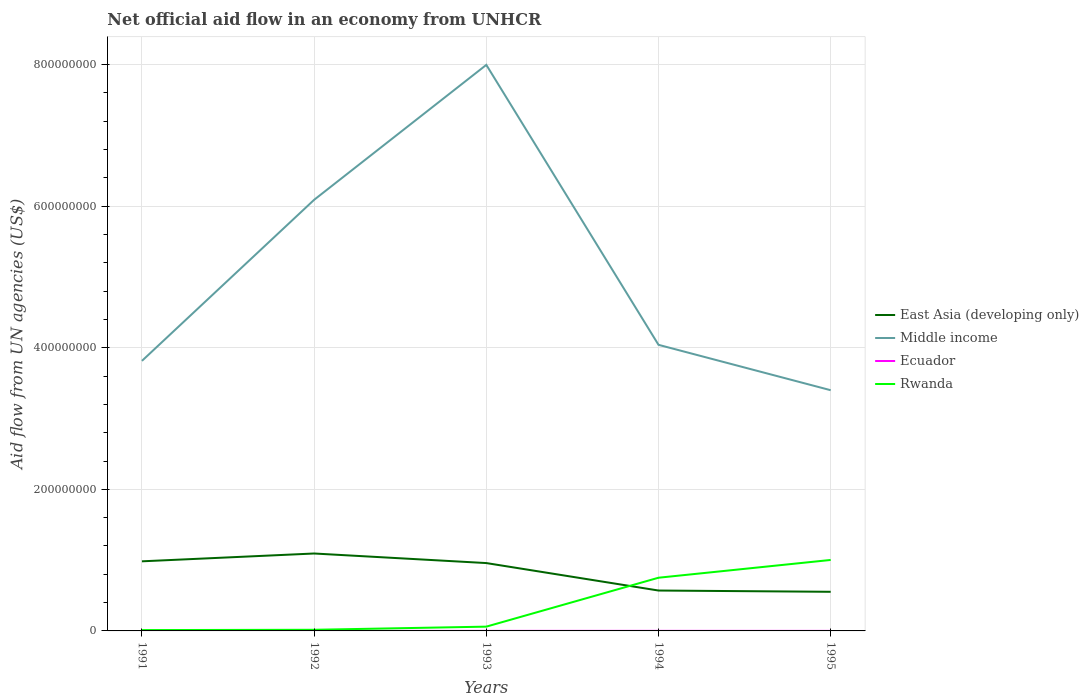Does the line corresponding to Middle income intersect with the line corresponding to East Asia (developing only)?
Provide a short and direct response. No. Across all years, what is the maximum net official aid flow in East Asia (developing only)?
Keep it short and to the point. 5.53e+07. What is the difference between the highest and the second highest net official aid flow in Rwanda?
Make the answer very short. 9.90e+07. How many lines are there?
Offer a terse response. 4. How many years are there in the graph?
Provide a succinct answer. 5. Are the values on the major ticks of Y-axis written in scientific E-notation?
Keep it short and to the point. No. How many legend labels are there?
Offer a terse response. 4. What is the title of the graph?
Give a very brief answer. Net official aid flow in an economy from UNHCR. Does "Luxembourg" appear as one of the legend labels in the graph?
Give a very brief answer. No. What is the label or title of the Y-axis?
Your answer should be compact. Aid flow from UN agencies (US$). What is the Aid flow from UN agencies (US$) in East Asia (developing only) in 1991?
Ensure brevity in your answer.  9.83e+07. What is the Aid flow from UN agencies (US$) of Middle income in 1991?
Keep it short and to the point. 3.81e+08. What is the Aid flow from UN agencies (US$) in Ecuador in 1991?
Keep it short and to the point. 1.00e+05. What is the Aid flow from UN agencies (US$) in Rwanda in 1991?
Make the answer very short. 1.20e+06. What is the Aid flow from UN agencies (US$) of East Asia (developing only) in 1992?
Give a very brief answer. 1.09e+08. What is the Aid flow from UN agencies (US$) of Middle income in 1992?
Offer a terse response. 6.09e+08. What is the Aid flow from UN agencies (US$) of Rwanda in 1992?
Keep it short and to the point. 1.61e+06. What is the Aid flow from UN agencies (US$) of East Asia (developing only) in 1993?
Provide a short and direct response. 9.58e+07. What is the Aid flow from UN agencies (US$) in Middle income in 1993?
Your answer should be very brief. 8.00e+08. What is the Aid flow from UN agencies (US$) of Ecuador in 1993?
Your answer should be very brief. 7.00e+04. What is the Aid flow from UN agencies (US$) in Rwanda in 1993?
Your answer should be compact. 6.05e+06. What is the Aid flow from UN agencies (US$) in East Asia (developing only) in 1994?
Keep it short and to the point. 5.70e+07. What is the Aid flow from UN agencies (US$) in Middle income in 1994?
Make the answer very short. 4.04e+08. What is the Aid flow from UN agencies (US$) in Ecuador in 1994?
Your response must be concise. 8.00e+04. What is the Aid flow from UN agencies (US$) of Rwanda in 1994?
Offer a very short reply. 7.51e+07. What is the Aid flow from UN agencies (US$) of East Asia (developing only) in 1995?
Your answer should be very brief. 5.53e+07. What is the Aid flow from UN agencies (US$) in Middle income in 1995?
Offer a terse response. 3.40e+08. What is the Aid flow from UN agencies (US$) in Ecuador in 1995?
Offer a terse response. 5.00e+04. What is the Aid flow from UN agencies (US$) in Rwanda in 1995?
Your answer should be very brief. 1.00e+08. Across all years, what is the maximum Aid flow from UN agencies (US$) of East Asia (developing only)?
Ensure brevity in your answer.  1.09e+08. Across all years, what is the maximum Aid flow from UN agencies (US$) in Middle income?
Your answer should be very brief. 8.00e+08. Across all years, what is the maximum Aid flow from UN agencies (US$) of Ecuador?
Offer a very short reply. 1.00e+05. Across all years, what is the maximum Aid flow from UN agencies (US$) in Rwanda?
Make the answer very short. 1.00e+08. Across all years, what is the minimum Aid flow from UN agencies (US$) of East Asia (developing only)?
Give a very brief answer. 5.53e+07. Across all years, what is the minimum Aid flow from UN agencies (US$) of Middle income?
Offer a terse response. 3.40e+08. Across all years, what is the minimum Aid flow from UN agencies (US$) of Ecuador?
Your answer should be compact. 5.00e+04. Across all years, what is the minimum Aid flow from UN agencies (US$) of Rwanda?
Your response must be concise. 1.20e+06. What is the total Aid flow from UN agencies (US$) of East Asia (developing only) in the graph?
Provide a short and direct response. 4.16e+08. What is the total Aid flow from UN agencies (US$) of Middle income in the graph?
Ensure brevity in your answer.  2.53e+09. What is the total Aid flow from UN agencies (US$) of Ecuador in the graph?
Your answer should be compact. 3.90e+05. What is the total Aid flow from UN agencies (US$) in Rwanda in the graph?
Keep it short and to the point. 1.84e+08. What is the difference between the Aid flow from UN agencies (US$) of East Asia (developing only) in 1991 and that in 1992?
Give a very brief answer. -1.10e+07. What is the difference between the Aid flow from UN agencies (US$) in Middle income in 1991 and that in 1992?
Give a very brief answer. -2.27e+08. What is the difference between the Aid flow from UN agencies (US$) of Ecuador in 1991 and that in 1992?
Offer a terse response. 10000. What is the difference between the Aid flow from UN agencies (US$) of Rwanda in 1991 and that in 1992?
Your answer should be compact. -4.10e+05. What is the difference between the Aid flow from UN agencies (US$) in East Asia (developing only) in 1991 and that in 1993?
Your answer should be compact. 2.47e+06. What is the difference between the Aid flow from UN agencies (US$) in Middle income in 1991 and that in 1993?
Ensure brevity in your answer.  -4.18e+08. What is the difference between the Aid flow from UN agencies (US$) of Rwanda in 1991 and that in 1993?
Provide a short and direct response. -4.85e+06. What is the difference between the Aid flow from UN agencies (US$) of East Asia (developing only) in 1991 and that in 1994?
Provide a short and direct response. 4.13e+07. What is the difference between the Aid flow from UN agencies (US$) in Middle income in 1991 and that in 1994?
Give a very brief answer. -2.27e+07. What is the difference between the Aid flow from UN agencies (US$) in Ecuador in 1991 and that in 1994?
Offer a terse response. 2.00e+04. What is the difference between the Aid flow from UN agencies (US$) in Rwanda in 1991 and that in 1994?
Offer a very short reply. -7.39e+07. What is the difference between the Aid flow from UN agencies (US$) of East Asia (developing only) in 1991 and that in 1995?
Offer a very short reply. 4.30e+07. What is the difference between the Aid flow from UN agencies (US$) in Middle income in 1991 and that in 1995?
Provide a short and direct response. 4.14e+07. What is the difference between the Aid flow from UN agencies (US$) in Ecuador in 1991 and that in 1995?
Offer a terse response. 5.00e+04. What is the difference between the Aid flow from UN agencies (US$) of Rwanda in 1991 and that in 1995?
Offer a terse response. -9.90e+07. What is the difference between the Aid flow from UN agencies (US$) of East Asia (developing only) in 1992 and that in 1993?
Provide a succinct answer. 1.35e+07. What is the difference between the Aid flow from UN agencies (US$) of Middle income in 1992 and that in 1993?
Provide a short and direct response. -1.91e+08. What is the difference between the Aid flow from UN agencies (US$) of Rwanda in 1992 and that in 1993?
Your response must be concise. -4.44e+06. What is the difference between the Aid flow from UN agencies (US$) of East Asia (developing only) in 1992 and that in 1994?
Give a very brief answer. 5.23e+07. What is the difference between the Aid flow from UN agencies (US$) in Middle income in 1992 and that in 1994?
Make the answer very short. 2.05e+08. What is the difference between the Aid flow from UN agencies (US$) of Rwanda in 1992 and that in 1994?
Your answer should be very brief. -7.35e+07. What is the difference between the Aid flow from UN agencies (US$) of East Asia (developing only) in 1992 and that in 1995?
Keep it short and to the point. 5.41e+07. What is the difference between the Aid flow from UN agencies (US$) in Middle income in 1992 and that in 1995?
Provide a short and direct response. 2.69e+08. What is the difference between the Aid flow from UN agencies (US$) in Rwanda in 1992 and that in 1995?
Make the answer very short. -9.86e+07. What is the difference between the Aid flow from UN agencies (US$) of East Asia (developing only) in 1993 and that in 1994?
Ensure brevity in your answer.  3.88e+07. What is the difference between the Aid flow from UN agencies (US$) in Middle income in 1993 and that in 1994?
Your response must be concise. 3.95e+08. What is the difference between the Aid flow from UN agencies (US$) of Ecuador in 1993 and that in 1994?
Offer a very short reply. -10000. What is the difference between the Aid flow from UN agencies (US$) in Rwanda in 1993 and that in 1994?
Keep it short and to the point. -6.91e+07. What is the difference between the Aid flow from UN agencies (US$) of East Asia (developing only) in 1993 and that in 1995?
Provide a succinct answer. 4.06e+07. What is the difference between the Aid flow from UN agencies (US$) in Middle income in 1993 and that in 1995?
Your answer should be very brief. 4.60e+08. What is the difference between the Aid flow from UN agencies (US$) of Ecuador in 1993 and that in 1995?
Offer a terse response. 2.00e+04. What is the difference between the Aid flow from UN agencies (US$) in Rwanda in 1993 and that in 1995?
Offer a terse response. -9.42e+07. What is the difference between the Aid flow from UN agencies (US$) in East Asia (developing only) in 1994 and that in 1995?
Keep it short and to the point. 1.78e+06. What is the difference between the Aid flow from UN agencies (US$) in Middle income in 1994 and that in 1995?
Offer a terse response. 6.41e+07. What is the difference between the Aid flow from UN agencies (US$) of Rwanda in 1994 and that in 1995?
Provide a succinct answer. -2.51e+07. What is the difference between the Aid flow from UN agencies (US$) of East Asia (developing only) in 1991 and the Aid flow from UN agencies (US$) of Middle income in 1992?
Offer a very short reply. -5.11e+08. What is the difference between the Aid flow from UN agencies (US$) in East Asia (developing only) in 1991 and the Aid flow from UN agencies (US$) in Ecuador in 1992?
Provide a short and direct response. 9.82e+07. What is the difference between the Aid flow from UN agencies (US$) of East Asia (developing only) in 1991 and the Aid flow from UN agencies (US$) of Rwanda in 1992?
Keep it short and to the point. 9.67e+07. What is the difference between the Aid flow from UN agencies (US$) of Middle income in 1991 and the Aid flow from UN agencies (US$) of Ecuador in 1992?
Give a very brief answer. 3.81e+08. What is the difference between the Aid flow from UN agencies (US$) of Middle income in 1991 and the Aid flow from UN agencies (US$) of Rwanda in 1992?
Provide a short and direct response. 3.80e+08. What is the difference between the Aid flow from UN agencies (US$) in Ecuador in 1991 and the Aid flow from UN agencies (US$) in Rwanda in 1992?
Ensure brevity in your answer.  -1.51e+06. What is the difference between the Aid flow from UN agencies (US$) in East Asia (developing only) in 1991 and the Aid flow from UN agencies (US$) in Middle income in 1993?
Keep it short and to the point. -7.01e+08. What is the difference between the Aid flow from UN agencies (US$) of East Asia (developing only) in 1991 and the Aid flow from UN agencies (US$) of Ecuador in 1993?
Give a very brief answer. 9.82e+07. What is the difference between the Aid flow from UN agencies (US$) in East Asia (developing only) in 1991 and the Aid flow from UN agencies (US$) in Rwanda in 1993?
Keep it short and to the point. 9.23e+07. What is the difference between the Aid flow from UN agencies (US$) in Middle income in 1991 and the Aid flow from UN agencies (US$) in Ecuador in 1993?
Your response must be concise. 3.81e+08. What is the difference between the Aid flow from UN agencies (US$) of Middle income in 1991 and the Aid flow from UN agencies (US$) of Rwanda in 1993?
Your answer should be compact. 3.75e+08. What is the difference between the Aid flow from UN agencies (US$) in Ecuador in 1991 and the Aid flow from UN agencies (US$) in Rwanda in 1993?
Provide a short and direct response. -5.95e+06. What is the difference between the Aid flow from UN agencies (US$) in East Asia (developing only) in 1991 and the Aid flow from UN agencies (US$) in Middle income in 1994?
Your answer should be very brief. -3.06e+08. What is the difference between the Aid flow from UN agencies (US$) in East Asia (developing only) in 1991 and the Aid flow from UN agencies (US$) in Ecuador in 1994?
Offer a terse response. 9.82e+07. What is the difference between the Aid flow from UN agencies (US$) in East Asia (developing only) in 1991 and the Aid flow from UN agencies (US$) in Rwanda in 1994?
Keep it short and to the point. 2.32e+07. What is the difference between the Aid flow from UN agencies (US$) of Middle income in 1991 and the Aid flow from UN agencies (US$) of Ecuador in 1994?
Your answer should be compact. 3.81e+08. What is the difference between the Aid flow from UN agencies (US$) in Middle income in 1991 and the Aid flow from UN agencies (US$) in Rwanda in 1994?
Keep it short and to the point. 3.06e+08. What is the difference between the Aid flow from UN agencies (US$) in Ecuador in 1991 and the Aid flow from UN agencies (US$) in Rwanda in 1994?
Offer a very short reply. -7.50e+07. What is the difference between the Aid flow from UN agencies (US$) in East Asia (developing only) in 1991 and the Aid flow from UN agencies (US$) in Middle income in 1995?
Keep it short and to the point. -2.42e+08. What is the difference between the Aid flow from UN agencies (US$) in East Asia (developing only) in 1991 and the Aid flow from UN agencies (US$) in Ecuador in 1995?
Your response must be concise. 9.83e+07. What is the difference between the Aid flow from UN agencies (US$) in East Asia (developing only) in 1991 and the Aid flow from UN agencies (US$) in Rwanda in 1995?
Ensure brevity in your answer.  -1.93e+06. What is the difference between the Aid flow from UN agencies (US$) of Middle income in 1991 and the Aid flow from UN agencies (US$) of Ecuador in 1995?
Give a very brief answer. 3.81e+08. What is the difference between the Aid flow from UN agencies (US$) in Middle income in 1991 and the Aid flow from UN agencies (US$) in Rwanda in 1995?
Your answer should be compact. 2.81e+08. What is the difference between the Aid flow from UN agencies (US$) in Ecuador in 1991 and the Aid flow from UN agencies (US$) in Rwanda in 1995?
Your answer should be compact. -1.00e+08. What is the difference between the Aid flow from UN agencies (US$) in East Asia (developing only) in 1992 and the Aid flow from UN agencies (US$) in Middle income in 1993?
Your response must be concise. -6.90e+08. What is the difference between the Aid flow from UN agencies (US$) in East Asia (developing only) in 1992 and the Aid flow from UN agencies (US$) in Ecuador in 1993?
Offer a very short reply. 1.09e+08. What is the difference between the Aid flow from UN agencies (US$) of East Asia (developing only) in 1992 and the Aid flow from UN agencies (US$) of Rwanda in 1993?
Your answer should be compact. 1.03e+08. What is the difference between the Aid flow from UN agencies (US$) of Middle income in 1992 and the Aid flow from UN agencies (US$) of Ecuador in 1993?
Provide a succinct answer. 6.09e+08. What is the difference between the Aid flow from UN agencies (US$) in Middle income in 1992 and the Aid flow from UN agencies (US$) in Rwanda in 1993?
Provide a succinct answer. 6.03e+08. What is the difference between the Aid flow from UN agencies (US$) in Ecuador in 1992 and the Aid flow from UN agencies (US$) in Rwanda in 1993?
Offer a very short reply. -5.96e+06. What is the difference between the Aid flow from UN agencies (US$) of East Asia (developing only) in 1992 and the Aid flow from UN agencies (US$) of Middle income in 1994?
Make the answer very short. -2.95e+08. What is the difference between the Aid flow from UN agencies (US$) in East Asia (developing only) in 1992 and the Aid flow from UN agencies (US$) in Ecuador in 1994?
Offer a very short reply. 1.09e+08. What is the difference between the Aid flow from UN agencies (US$) in East Asia (developing only) in 1992 and the Aid flow from UN agencies (US$) in Rwanda in 1994?
Ensure brevity in your answer.  3.42e+07. What is the difference between the Aid flow from UN agencies (US$) in Middle income in 1992 and the Aid flow from UN agencies (US$) in Ecuador in 1994?
Make the answer very short. 6.09e+08. What is the difference between the Aid flow from UN agencies (US$) of Middle income in 1992 and the Aid flow from UN agencies (US$) of Rwanda in 1994?
Keep it short and to the point. 5.34e+08. What is the difference between the Aid flow from UN agencies (US$) of Ecuador in 1992 and the Aid flow from UN agencies (US$) of Rwanda in 1994?
Keep it short and to the point. -7.50e+07. What is the difference between the Aid flow from UN agencies (US$) in East Asia (developing only) in 1992 and the Aid flow from UN agencies (US$) in Middle income in 1995?
Provide a short and direct response. -2.31e+08. What is the difference between the Aid flow from UN agencies (US$) in East Asia (developing only) in 1992 and the Aid flow from UN agencies (US$) in Ecuador in 1995?
Offer a terse response. 1.09e+08. What is the difference between the Aid flow from UN agencies (US$) in East Asia (developing only) in 1992 and the Aid flow from UN agencies (US$) in Rwanda in 1995?
Your response must be concise. 9.11e+06. What is the difference between the Aid flow from UN agencies (US$) in Middle income in 1992 and the Aid flow from UN agencies (US$) in Ecuador in 1995?
Ensure brevity in your answer.  6.09e+08. What is the difference between the Aid flow from UN agencies (US$) of Middle income in 1992 and the Aid flow from UN agencies (US$) of Rwanda in 1995?
Keep it short and to the point. 5.09e+08. What is the difference between the Aid flow from UN agencies (US$) of Ecuador in 1992 and the Aid flow from UN agencies (US$) of Rwanda in 1995?
Provide a succinct answer. -1.00e+08. What is the difference between the Aid flow from UN agencies (US$) in East Asia (developing only) in 1993 and the Aid flow from UN agencies (US$) in Middle income in 1994?
Your response must be concise. -3.08e+08. What is the difference between the Aid flow from UN agencies (US$) of East Asia (developing only) in 1993 and the Aid flow from UN agencies (US$) of Ecuador in 1994?
Your answer should be very brief. 9.58e+07. What is the difference between the Aid flow from UN agencies (US$) in East Asia (developing only) in 1993 and the Aid flow from UN agencies (US$) in Rwanda in 1994?
Ensure brevity in your answer.  2.07e+07. What is the difference between the Aid flow from UN agencies (US$) of Middle income in 1993 and the Aid flow from UN agencies (US$) of Ecuador in 1994?
Make the answer very short. 7.99e+08. What is the difference between the Aid flow from UN agencies (US$) of Middle income in 1993 and the Aid flow from UN agencies (US$) of Rwanda in 1994?
Offer a terse response. 7.24e+08. What is the difference between the Aid flow from UN agencies (US$) in Ecuador in 1993 and the Aid flow from UN agencies (US$) in Rwanda in 1994?
Keep it short and to the point. -7.51e+07. What is the difference between the Aid flow from UN agencies (US$) in East Asia (developing only) in 1993 and the Aid flow from UN agencies (US$) in Middle income in 1995?
Offer a very short reply. -2.44e+08. What is the difference between the Aid flow from UN agencies (US$) of East Asia (developing only) in 1993 and the Aid flow from UN agencies (US$) of Ecuador in 1995?
Your response must be concise. 9.58e+07. What is the difference between the Aid flow from UN agencies (US$) of East Asia (developing only) in 1993 and the Aid flow from UN agencies (US$) of Rwanda in 1995?
Offer a terse response. -4.40e+06. What is the difference between the Aid flow from UN agencies (US$) in Middle income in 1993 and the Aid flow from UN agencies (US$) in Ecuador in 1995?
Provide a short and direct response. 7.99e+08. What is the difference between the Aid flow from UN agencies (US$) of Middle income in 1993 and the Aid flow from UN agencies (US$) of Rwanda in 1995?
Provide a short and direct response. 6.99e+08. What is the difference between the Aid flow from UN agencies (US$) in Ecuador in 1993 and the Aid flow from UN agencies (US$) in Rwanda in 1995?
Offer a terse response. -1.00e+08. What is the difference between the Aid flow from UN agencies (US$) in East Asia (developing only) in 1994 and the Aid flow from UN agencies (US$) in Middle income in 1995?
Provide a succinct answer. -2.83e+08. What is the difference between the Aid flow from UN agencies (US$) of East Asia (developing only) in 1994 and the Aid flow from UN agencies (US$) of Ecuador in 1995?
Your answer should be very brief. 5.70e+07. What is the difference between the Aid flow from UN agencies (US$) in East Asia (developing only) in 1994 and the Aid flow from UN agencies (US$) in Rwanda in 1995?
Offer a very short reply. -4.32e+07. What is the difference between the Aid flow from UN agencies (US$) in Middle income in 1994 and the Aid flow from UN agencies (US$) in Ecuador in 1995?
Provide a short and direct response. 4.04e+08. What is the difference between the Aid flow from UN agencies (US$) of Middle income in 1994 and the Aid flow from UN agencies (US$) of Rwanda in 1995?
Make the answer very short. 3.04e+08. What is the difference between the Aid flow from UN agencies (US$) in Ecuador in 1994 and the Aid flow from UN agencies (US$) in Rwanda in 1995?
Make the answer very short. -1.00e+08. What is the average Aid flow from UN agencies (US$) of East Asia (developing only) per year?
Ensure brevity in your answer.  8.32e+07. What is the average Aid flow from UN agencies (US$) of Middle income per year?
Your response must be concise. 5.07e+08. What is the average Aid flow from UN agencies (US$) in Ecuador per year?
Your answer should be very brief. 7.80e+04. What is the average Aid flow from UN agencies (US$) of Rwanda per year?
Offer a very short reply. 3.68e+07. In the year 1991, what is the difference between the Aid flow from UN agencies (US$) of East Asia (developing only) and Aid flow from UN agencies (US$) of Middle income?
Provide a succinct answer. -2.83e+08. In the year 1991, what is the difference between the Aid flow from UN agencies (US$) of East Asia (developing only) and Aid flow from UN agencies (US$) of Ecuador?
Your answer should be compact. 9.82e+07. In the year 1991, what is the difference between the Aid flow from UN agencies (US$) of East Asia (developing only) and Aid flow from UN agencies (US$) of Rwanda?
Give a very brief answer. 9.71e+07. In the year 1991, what is the difference between the Aid flow from UN agencies (US$) of Middle income and Aid flow from UN agencies (US$) of Ecuador?
Provide a succinct answer. 3.81e+08. In the year 1991, what is the difference between the Aid flow from UN agencies (US$) in Middle income and Aid flow from UN agencies (US$) in Rwanda?
Keep it short and to the point. 3.80e+08. In the year 1991, what is the difference between the Aid flow from UN agencies (US$) in Ecuador and Aid flow from UN agencies (US$) in Rwanda?
Your response must be concise. -1.10e+06. In the year 1992, what is the difference between the Aid flow from UN agencies (US$) of East Asia (developing only) and Aid flow from UN agencies (US$) of Middle income?
Provide a succinct answer. -5.00e+08. In the year 1992, what is the difference between the Aid flow from UN agencies (US$) of East Asia (developing only) and Aid flow from UN agencies (US$) of Ecuador?
Offer a very short reply. 1.09e+08. In the year 1992, what is the difference between the Aid flow from UN agencies (US$) in East Asia (developing only) and Aid flow from UN agencies (US$) in Rwanda?
Provide a succinct answer. 1.08e+08. In the year 1992, what is the difference between the Aid flow from UN agencies (US$) in Middle income and Aid flow from UN agencies (US$) in Ecuador?
Your answer should be compact. 6.09e+08. In the year 1992, what is the difference between the Aid flow from UN agencies (US$) of Middle income and Aid flow from UN agencies (US$) of Rwanda?
Keep it short and to the point. 6.07e+08. In the year 1992, what is the difference between the Aid flow from UN agencies (US$) in Ecuador and Aid flow from UN agencies (US$) in Rwanda?
Provide a short and direct response. -1.52e+06. In the year 1993, what is the difference between the Aid flow from UN agencies (US$) of East Asia (developing only) and Aid flow from UN agencies (US$) of Middle income?
Offer a very short reply. -7.04e+08. In the year 1993, what is the difference between the Aid flow from UN agencies (US$) in East Asia (developing only) and Aid flow from UN agencies (US$) in Ecuador?
Ensure brevity in your answer.  9.58e+07. In the year 1993, what is the difference between the Aid flow from UN agencies (US$) of East Asia (developing only) and Aid flow from UN agencies (US$) of Rwanda?
Offer a terse response. 8.98e+07. In the year 1993, what is the difference between the Aid flow from UN agencies (US$) in Middle income and Aid flow from UN agencies (US$) in Ecuador?
Ensure brevity in your answer.  7.99e+08. In the year 1993, what is the difference between the Aid flow from UN agencies (US$) of Middle income and Aid flow from UN agencies (US$) of Rwanda?
Make the answer very short. 7.93e+08. In the year 1993, what is the difference between the Aid flow from UN agencies (US$) in Ecuador and Aid flow from UN agencies (US$) in Rwanda?
Offer a very short reply. -5.98e+06. In the year 1994, what is the difference between the Aid flow from UN agencies (US$) in East Asia (developing only) and Aid flow from UN agencies (US$) in Middle income?
Keep it short and to the point. -3.47e+08. In the year 1994, what is the difference between the Aid flow from UN agencies (US$) in East Asia (developing only) and Aid flow from UN agencies (US$) in Ecuador?
Keep it short and to the point. 5.70e+07. In the year 1994, what is the difference between the Aid flow from UN agencies (US$) of East Asia (developing only) and Aid flow from UN agencies (US$) of Rwanda?
Give a very brief answer. -1.81e+07. In the year 1994, what is the difference between the Aid flow from UN agencies (US$) of Middle income and Aid flow from UN agencies (US$) of Ecuador?
Provide a succinct answer. 4.04e+08. In the year 1994, what is the difference between the Aid flow from UN agencies (US$) in Middle income and Aid flow from UN agencies (US$) in Rwanda?
Make the answer very short. 3.29e+08. In the year 1994, what is the difference between the Aid flow from UN agencies (US$) of Ecuador and Aid flow from UN agencies (US$) of Rwanda?
Your answer should be very brief. -7.51e+07. In the year 1995, what is the difference between the Aid flow from UN agencies (US$) in East Asia (developing only) and Aid flow from UN agencies (US$) in Middle income?
Give a very brief answer. -2.85e+08. In the year 1995, what is the difference between the Aid flow from UN agencies (US$) in East Asia (developing only) and Aid flow from UN agencies (US$) in Ecuador?
Your answer should be compact. 5.52e+07. In the year 1995, what is the difference between the Aid flow from UN agencies (US$) in East Asia (developing only) and Aid flow from UN agencies (US$) in Rwanda?
Offer a very short reply. -4.50e+07. In the year 1995, what is the difference between the Aid flow from UN agencies (US$) in Middle income and Aid flow from UN agencies (US$) in Ecuador?
Offer a very short reply. 3.40e+08. In the year 1995, what is the difference between the Aid flow from UN agencies (US$) in Middle income and Aid flow from UN agencies (US$) in Rwanda?
Provide a succinct answer. 2.40e+08. In the year 1995, what is the difference between the Aid flow from UN agencies (US$) of Ecuador and Aid flow from UN agencies (US$) of Rwanda?
Your response must be concise. -1.00e+08. What is the ratio of the Aid flow from UN agencies (US$) in East Asia (developing only) in 1991 to that in 1992?
Keep it short and to the point. 0.9. What is the ratio of the Aid flow from UN agencies (US$) in Middle income in 1991 to that in 1992?
Offer a very short reply. 0.63. What is the ratio of the Aid flow from UN agencies (US$) in Ecuador in 1991 to that in 1992?
Keep it short and to the point. 1.11. What is the ratio of the Aid flow from UN agencies (US$) of Rwanda in 1991 to that in 1992?
Your response must be concise. 0.75. What is the ratio of the Aid flow from UN agencies (US$) of East Asia (developing only) in 1991 to that in 1993?
Your response must be concise. 1.03. What is the ratio of the Aid flow from UN agencies (US$) of Middle income in 1991 to that in 1993?
Your response must be concise. 0.48. What is the ratio of the Aid flow from UN agencies (US$) in Ecuador in 1991 to that in 1993?
Offer a terse response. 1.43. What is the ratio of the Aid flow from UN agencies (US$) in Rwanda in 1991 to that in 1993?
Keep it short and to the point. 0.2. What is the ratio of the Aid flow from UN agencies (US$) in East Asia (developing only) in 1991 to that in 1994?
Provide a succinct answer. 1.72. What is the ratio of the Aid flow from UN agencies (US$) in Middle income in 1991 to that in 1994?
Offer a terse response. 0.94. What is the ratio of the Aid flow from UN agencies (US$) in Rwanda in 1991 to that in 1994?
Ensure brevity in your answer.  0.02. What is the ratio of the Aid flow from UN agencies (US$) of East Asia (developing only) in 1991 to that in 1995?
Ensure brevity in your answer.  1.78. What is the ratio of the Aid flow from UN agencies (US$) of Middle income in 1991 to that in 1995?
Offer a terse response. 1.12. What is the ratio of the Aid flow from UN agencies (US$) of Ecuador in 1991 to that in 1995?
Keep it short and to the point. 2. What is the ratio of the Aid flow from UN agencies (US$) of Rwanda in 1991 to that in 1995?
Your response must be concise. 0.01. What is the ratio of the Aid flow from UN agencies (US$) of East Asia (developing only) in 1992 to that in 1993?
Give a very brief answer. 1.14. What is the ratio of the Aid flow from UN agencies (US$) in Middle income in 1992 to that in 1993?
Your answer should be compact. 0.76. What is the ratio of the Aid flow from UN agencies (US$) of Rwanda in 1992 to that in 1993?
Ensure brevity in your answer.  0.27. What is the ratio of the Aid flow from UN agencies (US$) in East Asia (developing only) in 1992 to that in 1994?
Offer a very short reply. 1.92. What is the ratio of the Aid flow from UN agencies (US$) of Middle income in 1992 to that in 1994?
Offer a terse response. 1.51. What is the ratio of the Aid flow from UN agencies (US$) in Ecuador in 1992 to that in 1994?
Give a very brief answer. 1.12. What is the ratio of the Aid flow from UN agencies (US$) of Rwanda in 1992 to that in 1994?
Provide a succinct answer. 0.02. What is the ratio of the Aid flow from UN agencies (US$) of East Asia (developing only) in 1992 to that in 1995?
Your answer should be very brief. 1.98. What is the ratio of the Aid flow from UN agencies (US$) in Middle income in 1992 to that in 1995?
Ensure brevity in your answer.  1.79. What is the ratio of the Aid flow from UN agencies (US$) of Rwanda in 1992 to that in 1995?
Offer a terse response. 0.02. What is the ratio of the Aid flow from UN agencies (US$) of East Asia (developing only) in 1993 to that in 1994?
Offer a very short reply. 1.68. What is the ratio of the Aid flow from UN agencies (US$) of Middle income in 1993 to that in 1994?
Make the answer very short. 1.98. What is the ratio of the Aid flow from UN agencies (US$) of Ecuador in 1993 to that in 1994?
Give a very brief answer. 0.88. What is the ratio of the Aid flow from UN agencies (US$) of Rwanda in 1993 to that in 1994?
Offer a terse response. 0.08. What is the ratio of the Aid flow from UN agencies (US$) in East Asia (developing only) in 1993 to that in 1995?
Offer a terse response. 1.73. What is the ratio of the Aid flow from UN agencies (US$) in Middle income in 1993 to that in 1995?
Ensure brevity in your answer.  2.35. What is the ratio of the Aid flow from UN agencies (US$) of Ecuador in 1993 to that in 1995?
Provide a short and direct response. 1.4. What is the ratio of the Aid flow from UN agencies (US$) of Rwanda in 1993 to that in 1995?
Provide a succinct answer. 0.06. What is the ratio of the Aid flow from UN agencies (US$) in East Asia (developing only) in 1994 to that in 1995?
Provide a short and direct response. 1.03. What is the ratio of the Aid flow from UN agencies (US$) of Middle income in 1994 to that in 1995?
Offer a terse response. 1.19. What is the ratio of the Aid flow from UN agencies (US$) in Ecuador in 1994 to that in 1995?
Offer a terse response. 1.6. What is the ratio of the Aid flow from UN agencies (US$) of Rwanda in 1994 to that in 1995?
Give a very brief answer. 0.75. What is the difference between the highest and the second highest Aid flow from UN agencies (US$) in East Asia (developing only)?
Provide a succinct answer. 1.10e+07. What is the difference between the highest and the second highest Aid flow from UN agencies (US$) in Middle income?
Make the answer very short. 1.91e+08. What is the difference between the highest and the second highest Aid flow from UN agencies (US$) of Ecuador?
Offer a very short reply. 10000. What is the difference between the highest and the second highest Aid flow from UN agencies (US$) of Rwanda?
Give a very brief answer. 2.51e+07. What is the difference between the highest and the lowest Aid flow from UN agencies (US$) of East Asia (developing only)?
Your answer should be compact. 5.41e+07. What is the difference between the highest and the lowest Aid flow from UN agencies (US$) of Middle income?
Offer a very short reply. 4.60e+08. What is the difference between the highest and the lowest Aid flow from UN agencies (US$) of Rwanda?
Your answer should be very brief. 9.90e+07. 